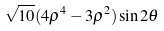<formula> <loc_0><loc_0><loc_500><loc_500>\sqrt { 1 0 } ( 4 \rho ^ { 4 } - 3 \rho ^ { 2 } ) \sin 2 \theta</formula> 